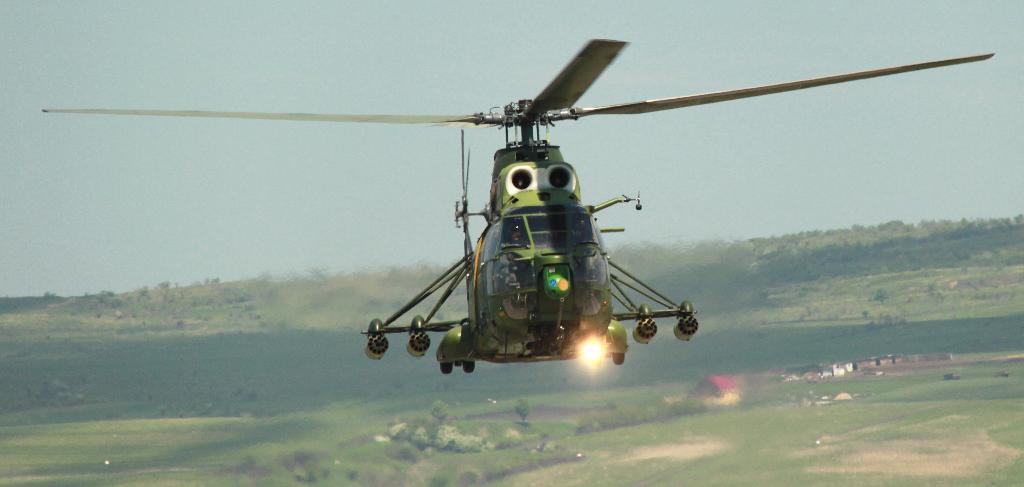In one or two sentences, can you explain what this image depicts? In this image we can see a few a helicopter flying in the sky, there are trees, and houses. 